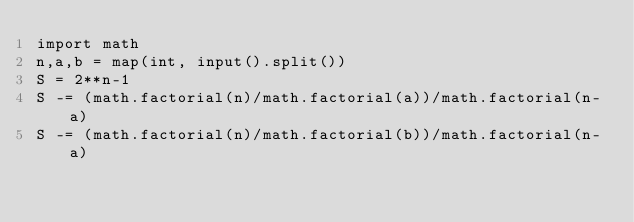Convert code to text. <code><loc_0><loc_0><loc_500><loc_500><_Python_>import math
n,a,b = map(int, input().split())
S = 2**n-1
S -= (math.factorial(n)/math.factorial(a))/math.factorial(n-a)
S -= (math.factorial(n)/math.factorial(b))/math.factorial(n-a)</code> 